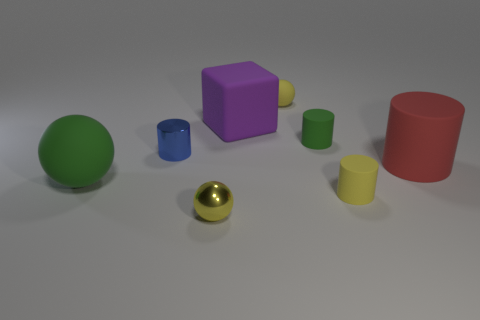There is a blue cylinder that is the same size as the yellow rubber ball; what is its material?
Your response must be concise. Metal. There is a green object that is in front of the big red matte object; how big is it?
Offer a very short reply. Large. Is the shape of the green matte thing that is left of the small yellow metal sphere the same as  the yellow metallic object?
Keep it short and to the point. Yes. There is a small yellow object that is the same shape as the small green object; what is its material?
Make the answer very short. Rubber. Is there a small brown rubber ball?
Give a very brief answer. No. What material is the small cylinder that is to the left of the tiny sphere that is in front of the small yellow matte object that is to the left of the tiny yellow rubber cylinder made of?
Provide a short and direct response. Metal. Does the red rubber thing have the same shape as the small yellow matte thing in front of the big rubber cube?
Give a very brief answer. Yes. How many large red matte objects have the same shape as the purple object?
Your answer should be very brief. 0. There is a blue thing; what shape is it?
Ensure brevity in your answer.  Cylinder. What size is the metallic object that is in front of the matte cylinder that is on the right side of the yellow cylinder?
Provide a short and direct response. Small. 